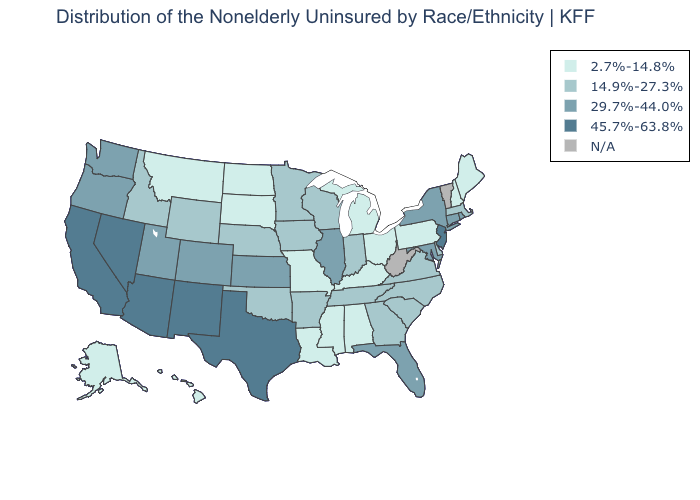Does Arkansas have the lowest value in the USA?
Quick response, please. No. Does the first symbol in the legend represent the smallest category?
Give a very brief answer. Yes. Among the states that border Kansas , which have the highest value?
Give a very brief answer. Colorado. Name the states that have a value in the range 45.7%-63.8%?
Be succinct. Arizona, California, Nevada, New Jersey, New Mexico, Texas. Which states have the lowest value in the Northeast?
Short answer required. Maine, New Hampshire, Pennsylvania. What is the value of Pennsylvania?
Short answer required. 2.7%-14.8%. Name the states that have a value in the range 29.7%-44.0%?
Concise answer only. Colorado, Connecticut, Florida, Illinois, Kansas, Maryland, New York, Oregon, Rhode Island, Utah, Washington. Among the states that border Colorado , does New Mexico have the highest value?
Keep it brief. Yes. Among the states that border Maryland , does Virginia have the highest value?
Quick response, please. Yes. Name the states that have a value in the range 14.9%-27.3%?
Answer briefly. Arkansas, Delaware, Georgia, Idaho, Indiana, Iowa, Massachusetts, Minnesota, Nebraska, North Carolina, Oklahoma, South Carolina, Tennessee, Virginia, Wisconsin, Wyoming. Name the states that have a value in the range 29.7%-44.0%?
Give a very brief answer. Colorado, Connecticut, Florida, Illinois, Kansas, Maryland, New York, Oregon, Rhode Island, Utah, Washington. What is the value of New Mexico?
Keep it brief. 45.7%-63.8%. Name the states that have a value in the range 45.7%-63.8%?
Concise answer only. Arizona, California, Nevada, New Jersey, New Mexico, Texas. What is the value of Delaware?
Keep it brief. 14.9%-27.3%. What is the value of Indiana?
Keep it brief. 14.9%-27.3%. 